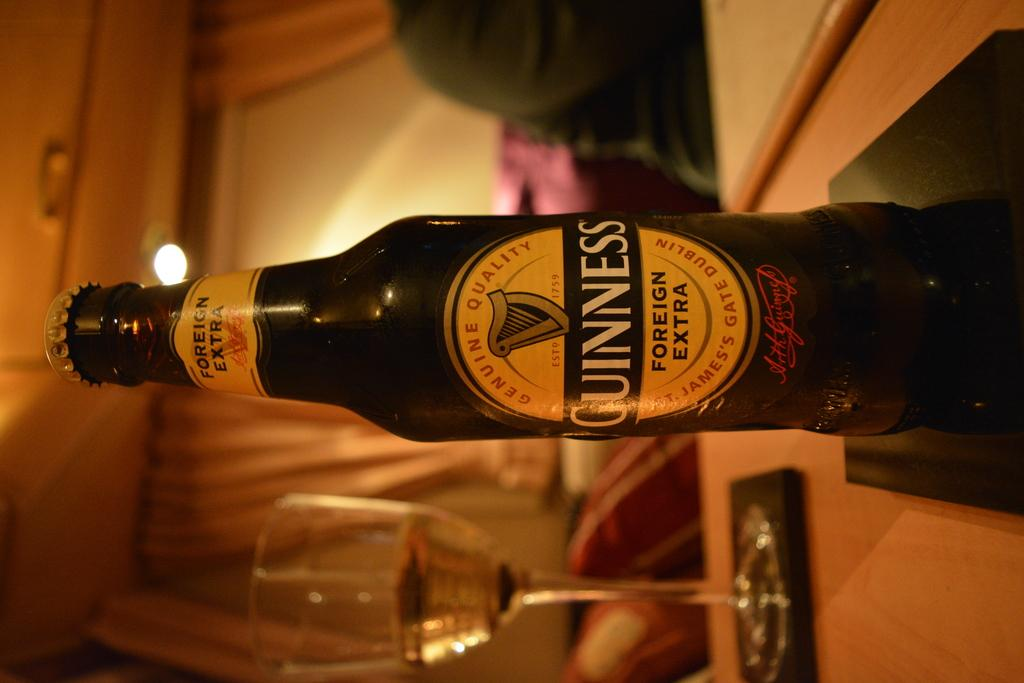<image>
Share a concise interpretation of the image provided. the word Guiness that is on the front of a bottle 